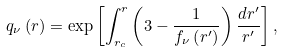<formula> <loc_0><loc_0><loc_500><loc_500>q _ { \nu } \left ( r \right ) = \exp \left [ \int _ { r _ { c } } ^ { r } \left ( 3 - \frac { 1 } { f _ { \nu } \left ( r ^ { \prime } \right ) } \right ) \frac { d r ^ { \prime } } { r ^ { \prime } } \right ] ,</formula> 